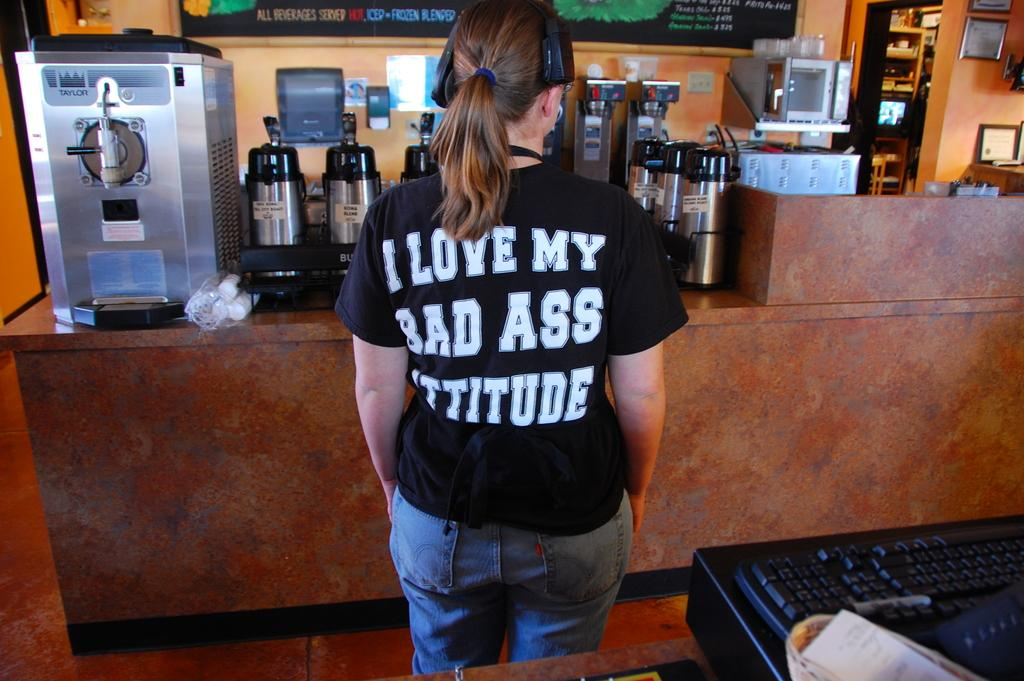Provide a one-sentence caption for the provided image. a girl wearing a shirt saying I Love My waiting for a coffee order. 